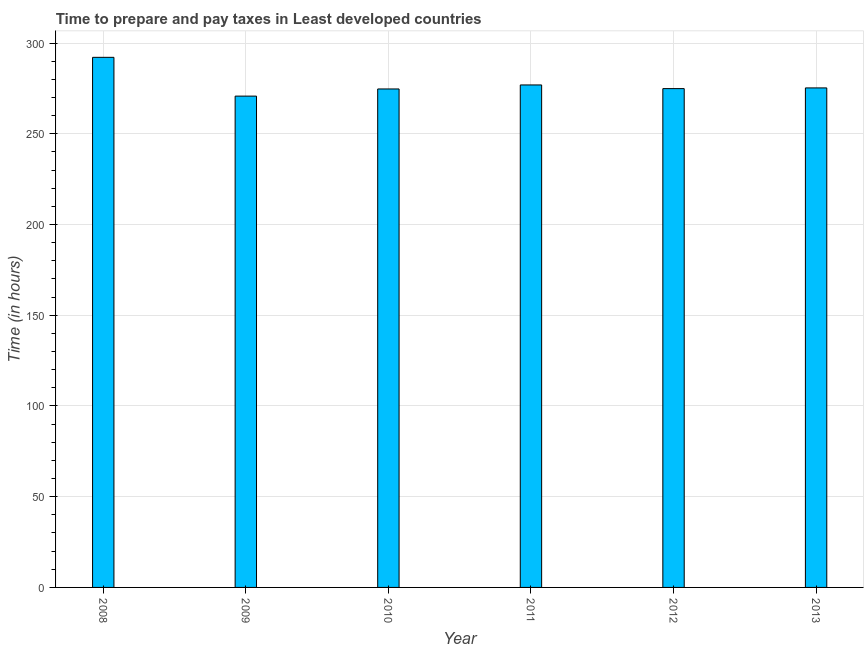Does the graph contain grids?
Provide a short and direct response. Yes. What is the title of the graph?
Ensure brevity in your answer.  Time to prepare and pay taxes in Least developed countries. What is the label or title of the Y-axis?
Provide a succinct answer. Time (in hours). What is the time to prepare and pay taxes in 2012?
Your answer should be very brief. 274.9. Across all years, what is the maximum time to prepare and pay taxes?
Ensure brevity in your answer.  292.14. Across all years, what is the minimum time to prepare and pay taxes?
Provide a succinct answer. 270.77. In which year was the time to prepare and pay taxes maximum?
Ensure brevity in your answer.  2008. In which year was the time to prepare and pay taxes minimum?
Provide a short and direct response. 2009. What is the sum of the time to prepare and pay taxes?
Offer a terse response. 1664.71. What is the difference between the time to prepare and pay taxes in 2010 and 2012?
Your answer should be very brief. -0.2. What is the average time to prepare and pay taxes per year?
Your answer should be very brief. 277.45. What is the median time to prepare and pay taxes?
Make the answer very short. 275.09. In how many years, is the time to prepare and pay taxes greater than 10 hours?
Keep it short and to the point. 6. What is the ratio of the time to prepare and pay taxes in 2008 to that in 2013?
Make the answer very short. 1.06. Is the time to prepare and pay taxes in 2008 less than that in 2011?
Offer a very short reply. No. What is the difference between the highest and the second highest time to prepare and pay taxes?
Offer a very short reply. 15.22. What is the difference between the highest and the lowest time to prepare and pay taxes?
Keep it short and to the point. 21.37. Are all the bars in the graph horizontal?
Give a very brief answer. No. What is the difference between two consecutive major ticks on the Y-axis?
Ensure brevity in your answer.  50. Are the values on the major ticks of Y-axis written in scientific E-notation?
Offer a terse response. No. What is the Time (in hours) in 2008?
Your answer should be very brief. 292.14. What is the Time (in hours) of 2009?
Provide a succinct answer. 270.77. What is the Time (in hours) of 2010?
Provide a succinct answer. 274.7. What is the Time (in hours) in 2011?
Your answer should be compact. 276.92. What is the Time (in hours) of 2012?
Provide a succinct answer. 274.9. What is the Time (in hours) in 2013?
Provide a short and direct response. 275.28. What is the difference between the Time (in hours) in 2008 and 2009?
Provide a short and direct response. 21.37. What is the difference between the Time (in hours) in 2008 and 2010?
Keep it short and to the point. 17.43. What is the difference between the Time (in hours) in 2008 and 2011?
Give a very brief answer. 15.22. What is the difference between the Time (in hours) in 2008 and 2012?
Ensure brevity in your answer.  17.24. What is the difference between the Time (in hours) in 2008 and 2013?
Give a very brief answer. 16.86. What is the difference between the Time (in hours) in 2009 and 2010?
Make the answer very short. -3.94. What is the difference between the Time (in hours) in 2009 and 2011?
Keep it short and to the point. -6.15. What is the difference between the Time (in hours) in 2009 and 2012?
Provide a short and direct response. -4.13. What is the difference between the Time (in hours) in 2009 and 2013?
Keep it short and to the point. -4.52. What is the difference between the Time (in hours) in 2010 and 2011?
Give a very brief answer. -2.21. What is the difference between the Time (in hours) in 2010 and 2012?
Provide a short and direct response. -0.2. What is the difference between the Time (in hours) in 2010 and 2013?
Your answer should be very brief. -0.58. What is the difference between the Time (in hours) in 2011 and 2012?
Provide a short and direct response. 2.02. What is the difference between the Time (in hours) in 2011 and 2013?
Give a very brief answer. 1.64. What is the difference between the Time (in hours) in 2012 and 2013?
Provide a short and direct response. -0.38. What is the ratio of the Time (in hours) in 2008 to that in 2009?
Give a very brief answer. 1.08. What is the ratio of the Time (in hours) in 2008 to that in 2010?
Provide a short and direct response. 1.06. What is the ratio of the Time (in hours) in 2008 to that in 2011?
Ensure brevity in your answer.  1.05. What is the ratio of the Time (in hours) in 2008 to that in 2012?
Your response must be concise. 1.06. What is the ratio of the Time (in hours) in 2008 to that in 2013?
Ensure brevity in your answer.  1.06. What is the ratio of the Time (in hours) in 2009 to that in 2010?
Your response must be concise. 0.99. What is the ratio of the Time (in hours) in 2009 to that in 2011?
Keep it short and to the point. 0.98. What is the ratio of the Time (in hours) in 2009 to that in 2012?
Provide a short and direct response. 0.98. What is the ratio of the Time (in hours) in 2009 to that in 2013?
Provide a short and direct response. 0.98. What is the ratio of the Time (in hours) in 2010 to that in 2011?
Your answer should be very brief. 0.99. What is the ratio of the Time (in hours) in 2010 to that in 2012?
Make the answer very short. 1. What is the ratio of the Time (in hours) in 2010 to that in 2013?
Provide a succinct answer. 1. What is the ratio of the Time (in hours) in 2011 to that in 2013?
Provide a short and direct response. 1.01. What is the ratio of the Time (in hours) in 2012 to that in 2013?
Offer a terse response. 1. 